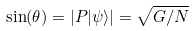<formula> <loc_0><loc_0><loc_500><loc_500>\sin ( \theta ) = | P | \psi \rangle | = { \sqrt { G / N } }</formula> 